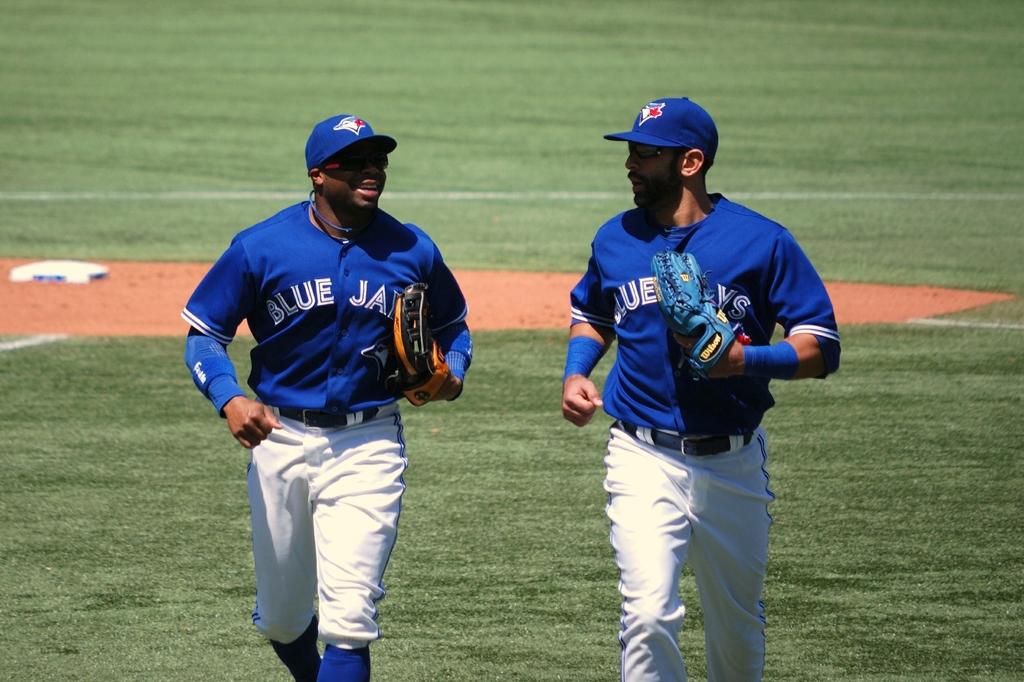What team name is on the front of the jerseys?
Your answer should be compact. Blue jays. What team are they on?
Your response must be concise. Blue jays. 